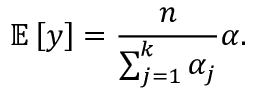<formula> <loc_0><loc_0><loc_500><loc_500>\mathbb { E } \left [ \boldsymbol y \right ] = \frac { n } { \sum _ { j = 1 } ^ { k } \alpha _ { j } } \boldsymbol \alpha .</formula> 